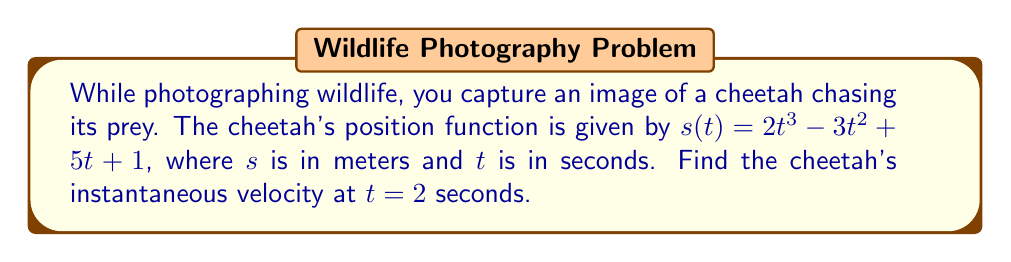Give your solution to this math problem. To find the instantaneous velocity, we need to calculate the derivative of the position function and evaluate it at the given time.

Step 1: Find the derivative of $s(t)$.
The position function is $s(t) = 2t^3 - 3t^2 + 5t + 1$
Using the power rule and constant rule:
$$\frac{d}{dt}[s(t)] = \frac{d}{dt}[2t^3 - 3t^2 + 5t + 1]$$
$$v(t) = 6t^2 - 6t + 5$$

Step 2: Evaluate the velocity function at $t = 2$ seconds.
$$v(2) = 6(2)^2 - 6(2) + 5$$
$$v(2) = 6(4) - 12 + 5$$
$$v(2) = 24 - 12 + 5$$
$$v(2) = 17$$

Therefore, the instantaneous velocity of the cheetah at $t = 2$ seconds is 17 m/s.
Answer: 17 m/s 